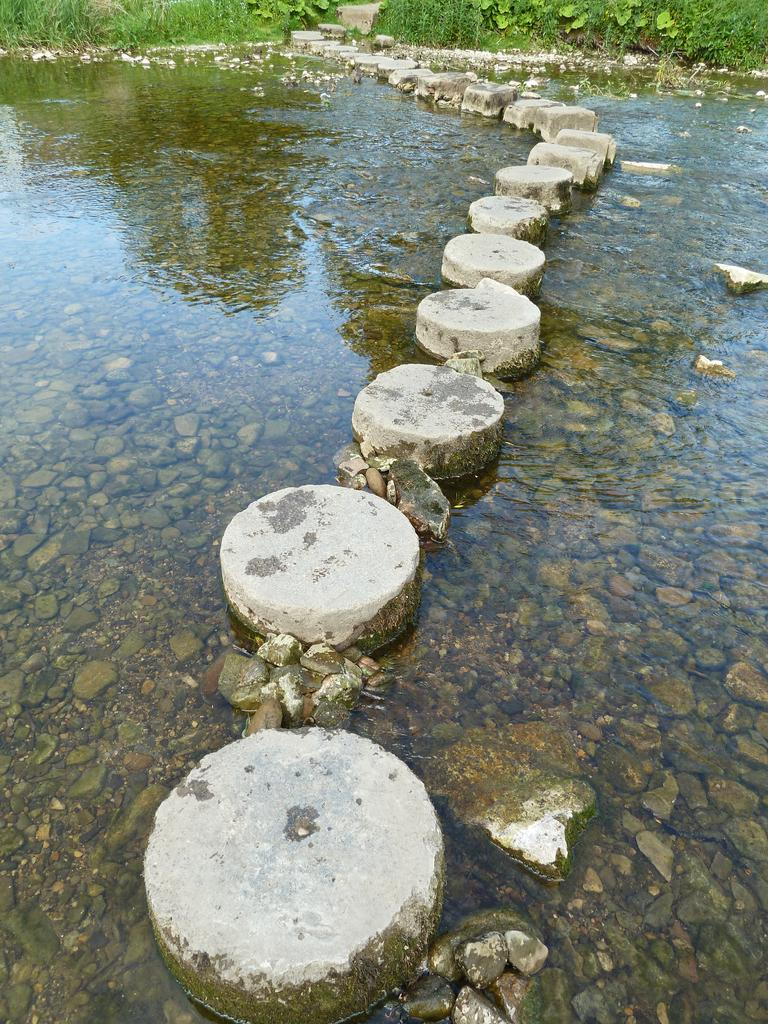What is the main feature in the center of the image? There is a pond in the center of the image. What can be found inside the pond? There are rocks and stones in the pond. What is visible in the background of the image? There are trees in the background of the image. What type of country is depicted in the image? There is no country depicted in the image; it features a pond with rocks and stones, surrounded by trees. What kind of pencil can be seen being used to take a test in the image? There is no pencil or test present in the image. 